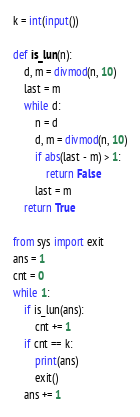<code> <loc_0><loc_0><loc_500><loc_500><_Python_>k = int(input())

def is_lun(n):
    d, m = divmod(n, 10)
    last = m
    while d:
        n = d
        d, m = divmod(n, 10)
        if abs(last - m) > 1:
            return False
        last = m
    return True

from sys import exit
ans = 1
cnt = 0
while 1:
    if is_lun(ans):
        cnt += 1
    if cnt == k:
        print(ans)
        exit()
    ans += 1</code> 